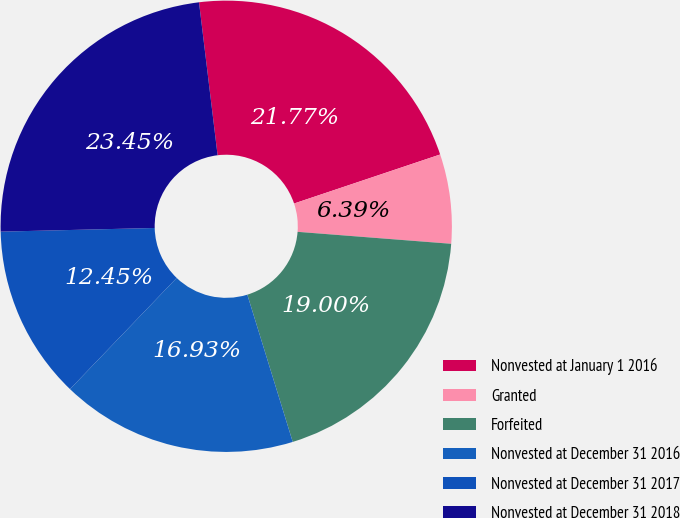<chart> <loc_0><loc_0><loc_500><loc_500><pie_chart><fcel>Nonvested at January 1 2016<fcel>Granted<fcel>Forfeited<fcel>Nonvested at December 31 2016<fcel>Nonvested at December 31 2017<fcel>Nonvested at December 31 2018<nl><fcel>21.77%<fcel>6.39%<fcel>19.0%<fcel>16.93%<fcel>12.45%<fcel>23.45%<nl></chart> 